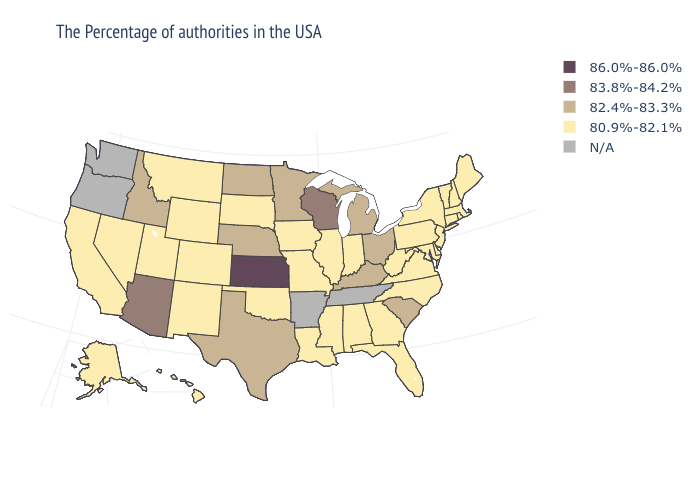Name the states that have a value in the range 80.9%-82.1%?
Give a very brief answer. Maine, Massachusetts, Rhode Island, New Hampshire, Vermont, Connecticut, New York, New Jersey, Delaware, Maryland, Pennsylvania, Virginia, North Carolina, West Virginia, Florida, Georgia, Indiana, Alabama, Illinois, Mississippi, Louisiana, Missouri, Iowa, Oklahoma, South Dakota, Wyoming, Colorado, New Mexico, Utah, Montana, Nevada, California, Alaska, Hawaii. What is the value of North Dakota?
Keep it brief. 82.4%-83.3%. Name the states that have a value in the range 86.0%-86.0%?
Concise answer only. Kansas. What is the value of Utah?
Be succinct. 80.9%-82.1%. Name the states that have a value in the range N/A?
Write a very short answer. Tennessee, Arkansas, Washington, Oregon. Does Iowa have the lowest value in the MidWest?
Keep it brief. Yes. Which states have the highest value in the USA?
Concise answer only. Kansas. What is the lowest value in the USA?
Keep it brief. 80.9%-82.1%. Does Idaho have the lowest value in the West?
Keep it brief. No. What is the highest value in the USA?
Quick response, please. 86.0%-86.0%. Does West Virginia have the lowest value in the USA?
Give a very brief answer. Yes. Name the states that have a value in the range 86.0%-86.0%?
Answer briefly. Kansas. Does Kansas have the highest value in the USA?
Concise answer only. Yes. 